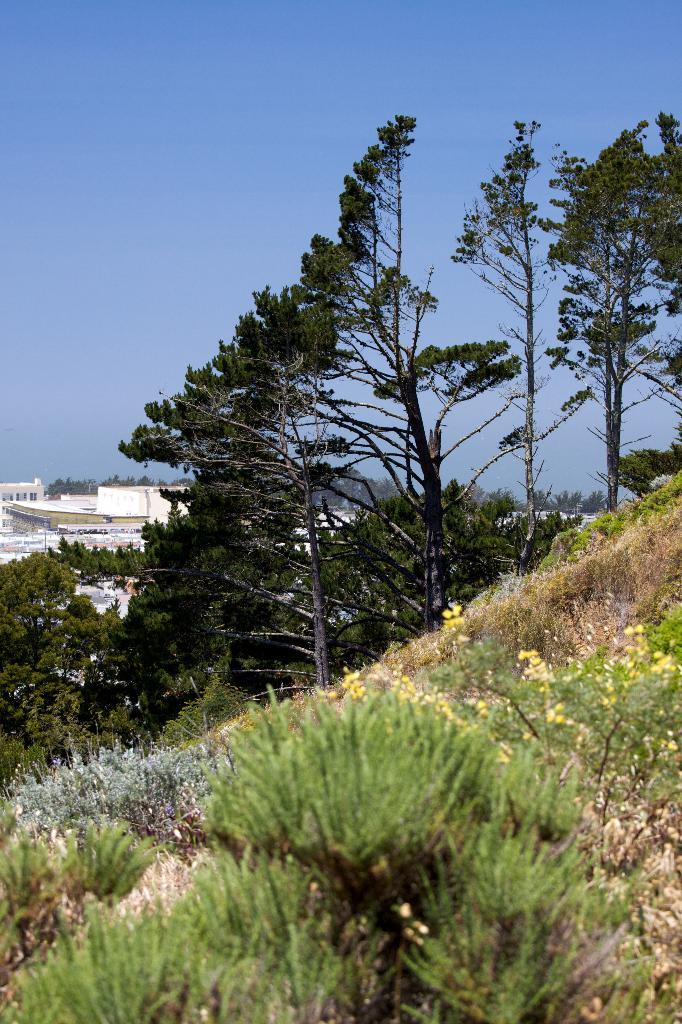Where was the picture taken? The picture was clicked outside. What can be seen in the foreground of the image? There are plants, grass, and trees in the foreground. What is visible in the background of the image? The sky is visible in the background, along with houses. What type of disgusting appliance can be seen in the image? A: There is no appliance, disgusting or otherwise, present in the image, as it is an outdoor scene with plants, grass, trees, sky, and houses. 